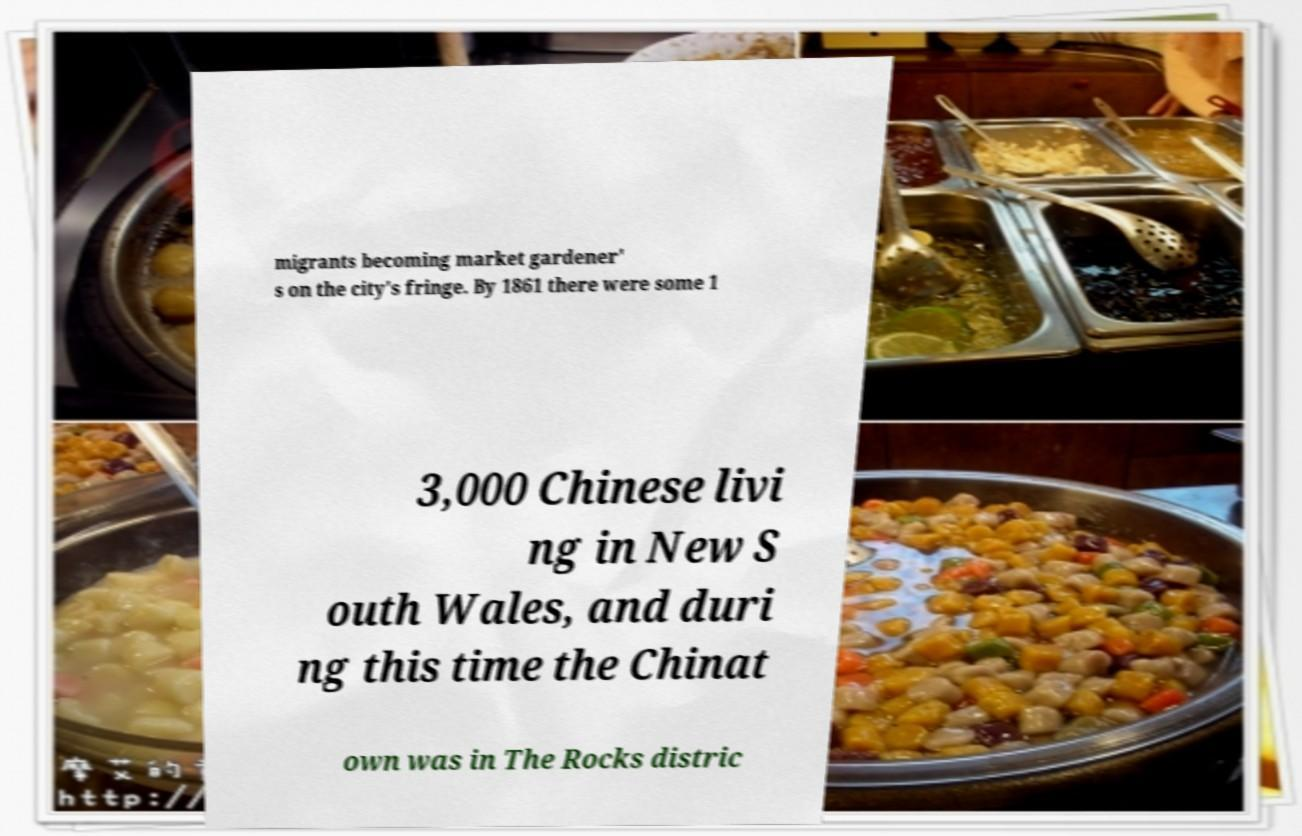Can you accurately transcribe the text from the provided image for me? migrants becoming market gardener' s on the city's fringe. By 1861 there were some 1 3,000 Chinese livi ng in New S outh Wales, and duri ng this time the Chinat own was in The Rocks distric 